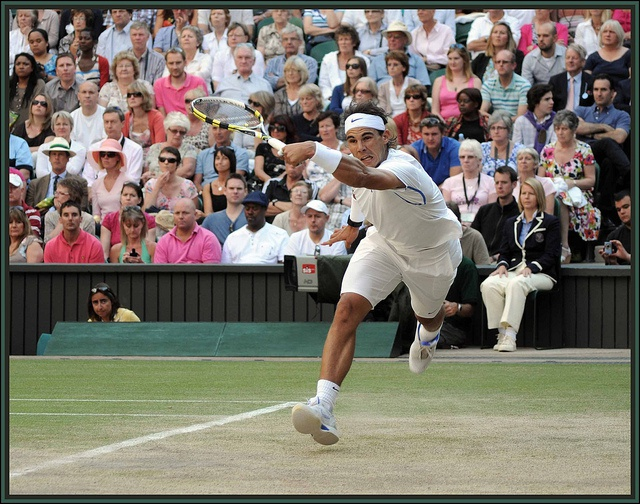Describe the objects in this image and their specific colors. I can see people in black, darkgray, lightgray, and gray tones, people in black, darkgray, lightgray, and gray tones, people in black, white, and darkgray tones, people in black, violet, brown, and lightpink tones, and tennis racket in black, darkgray, ivory, and gray tones in this image. 